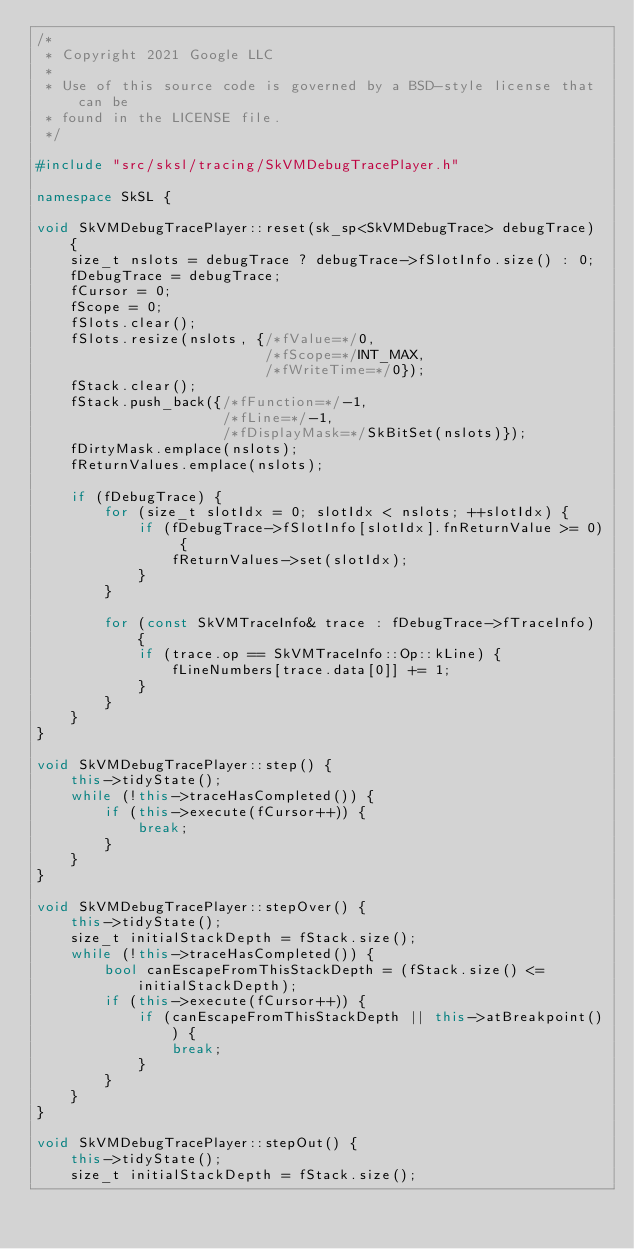<code> <loc_0><loc_0><loc_500><loc_500><_C++_>/*
 * Copyright 2021 Google LLC
 *
 * Use of this source code is governed by a BSD-style license that can be
 * found in the LICENSE file.
 */

#include "src/sksl/tracing/SkVMDebugTracePlayer.h"

namespace SkSL {

void SkVMDebugTracePlayer::reset(sk_sp<SkVMDebugTrace> debugTrace) {
    size_t nslots = debugTrace ? debugTrace->fSlotInfo.size() : 0;
    fDebugTrace = debugTrace;
    fCursor = 0;
    fScope = 0;
    fSlots.clear();
    fSlots.resize(nslots, {/*fValue=*/0,
                           /*fScope=*/INT_MAX,
                           /*fWriteTime=*/0});
    fStack.clear();
    fStack.push_back({/*fFunction=*/-1,
                      /*fLine=*/-1,
                      /*fDisplayMask=*/SkBitSet(nslots)});
    fDirtyMask.emplace(nslots);
    fReturnValues.emplace(nslots);

    if (fDebugTrace) {
        for (size_t slotIdx = 0; slotIdx < nslots; ++slotIdx) {
            if (fDebugTrace->fSlotInfo[slotIdx].fnReturnValue >= 0) {
                fReturnValues->set(slotIdx);
            }
        }

        for (const SkVMTraceInfo& trace : fDebugTrace->fTraceInfo) {
            if (trace.op == SkVMTraceInfo::Op::kLine) {
                fLineNumbers[trace.data[0]] += 1;
            }
        }
    }
}

void SkVMDebugTracePlayer::step() {
    this->tidyState();
    while (!this->traceHasCompleted()) {
        if (this->execute(fCursor++)) {
            break;
        }
    }
}

void SkVMDebugTracePlayer::stepOver() {
    this->tidyState();
    size_t initialStackDepth = fStack.size();
    while (!this->traceHasCompleted()) {
        bool canEscapeFromThisStackDepth = (fStack.size() <= initialStackDepth);
        if (this->execute(fCursor++)) {
            if (canEscapeFromThisStackDepth || this->atBreakpoint()) {
                break;
            }
        }
    }
}

void SkVMDebugTracePlayer::stepOut() {
    this->tidyState();
    size_t initialStackDepth = fStack.size();</code> 